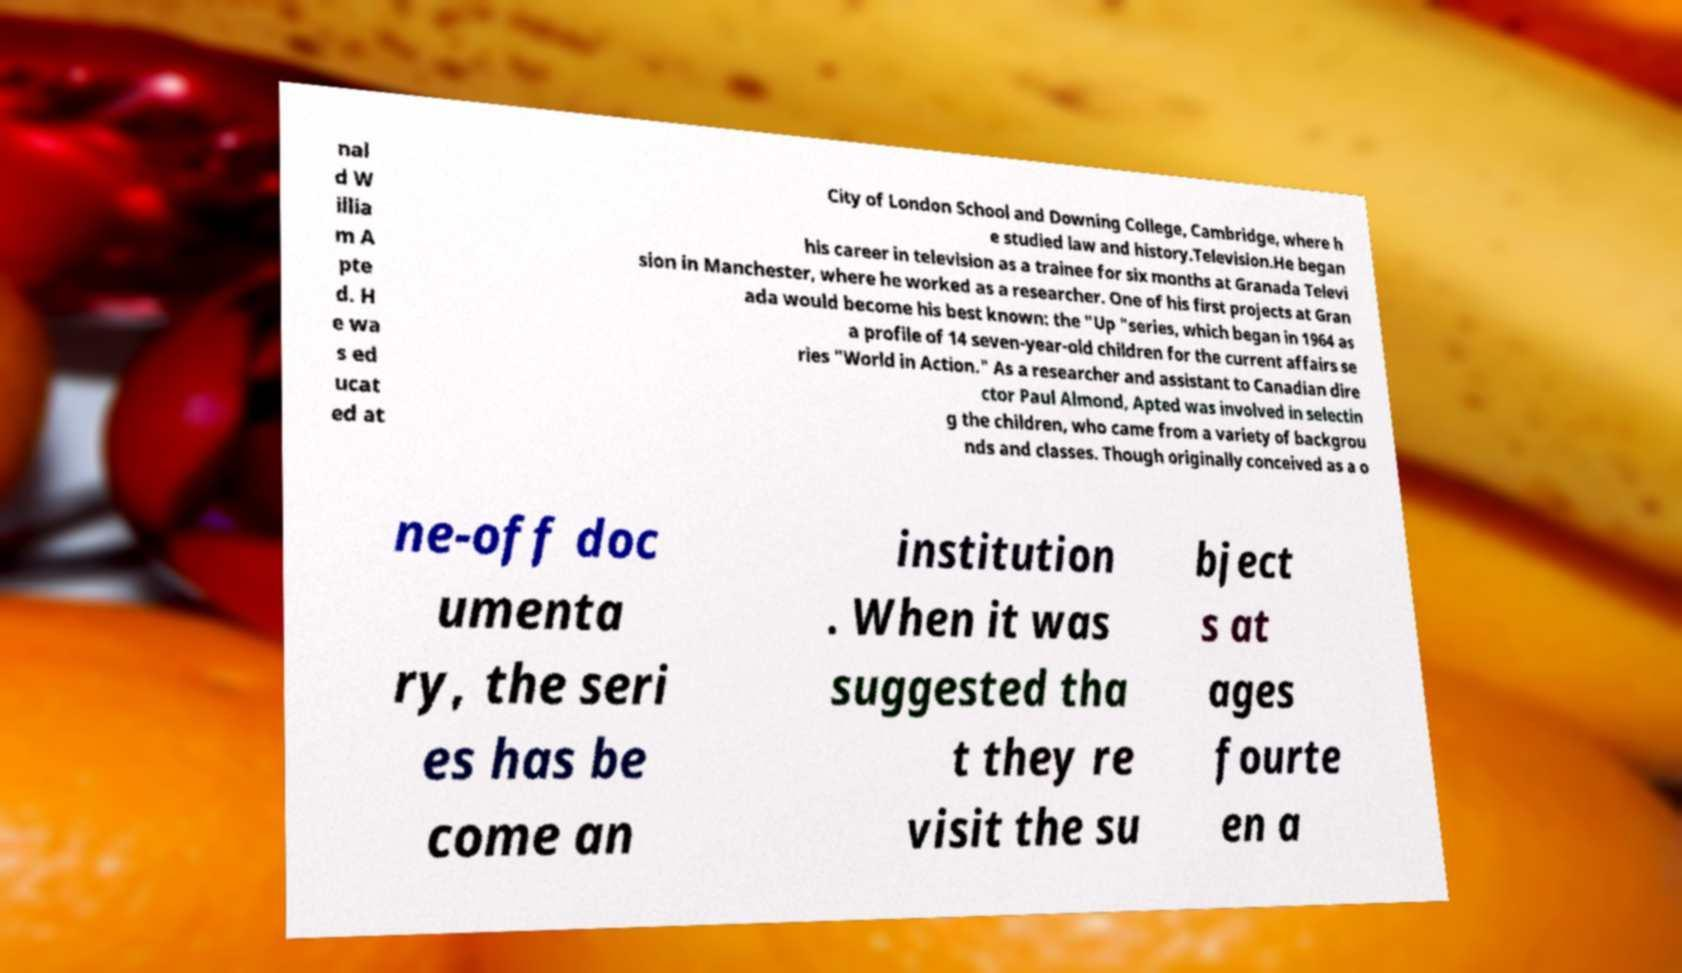Could you extract and type out the text from this image? nal d W illia m A pte d. H e wa s ed ucat ed at City of London School and Downing College, Cambridge, where h e studied law and history.Television.He began his career in television as a trainee for six months at Granada Televi sion in Manchester, where he worked as a researcher. One of his first projects at Gran ada would become his best known: the "Up "series, which began in 1964 as a profile of 14 seven-year-old children for the current affairs se ries "World in Action." As a researcher and assistant to Canadian dire ctor Paul Almond, Apted was involved in selectin g the children, who came from a variety of backgrou nds and classes. Though originally conceived as a o ne-off doc umenta ry, the seri es has be come an institution . When it was suggested tha t they re visit the su bject s at ages fourte en a 